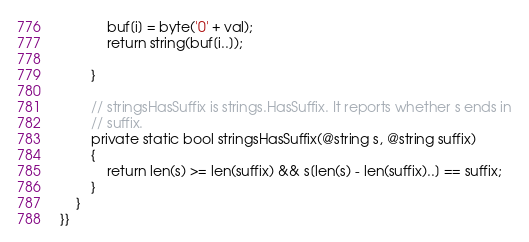Convert code to text. <code><loc_0><loc_0><loc_500><loc_500><_C#_>            buf[i] = byte('0' + val);
            return string(buf[i..]);

        }

        // stringsHasSuffix is strings.HasSuffix. It reports whether s ends in
        // suffix.
        private static bool stringsHasSuffix(@string s, @string suffix)
        {
            return len(s) >= len(suffix) && s[len(s) - len(suffix)..] == suffix;
        }
    }
}}
</code> 